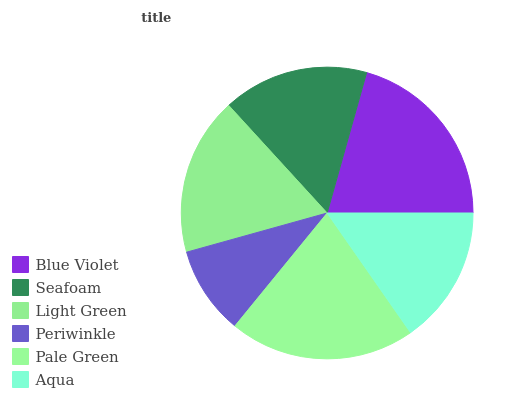Is Periwinkle the minimum?
Answer yes or no. Yes. Is Blue Violet the maximum?
Answer yes or no. Yes. Is Seafoam the minimum?
Answer yes or no. No. Is Seafoam the maximum?
Answer yes or no. No. Is Blue Violet greater than Seafoam?
Answer yes or no. Yes. Is Seafoam less than Blue Violet?
Answer yes or no. Yes. Is Seafoam greater than Blue Violet?
Answer yes or no. No. Is Blue Violet less than Seafoam?
Answer yes or no. No. Is Light Green the high median?
Answer yes or no. Yes. Is Seafoam the low median?
Answer yes or no. Yes. Is Periwinkle the high median?
Answer yes or no. No. Is Periwinkle the low median?
Answer yes or no. No. 